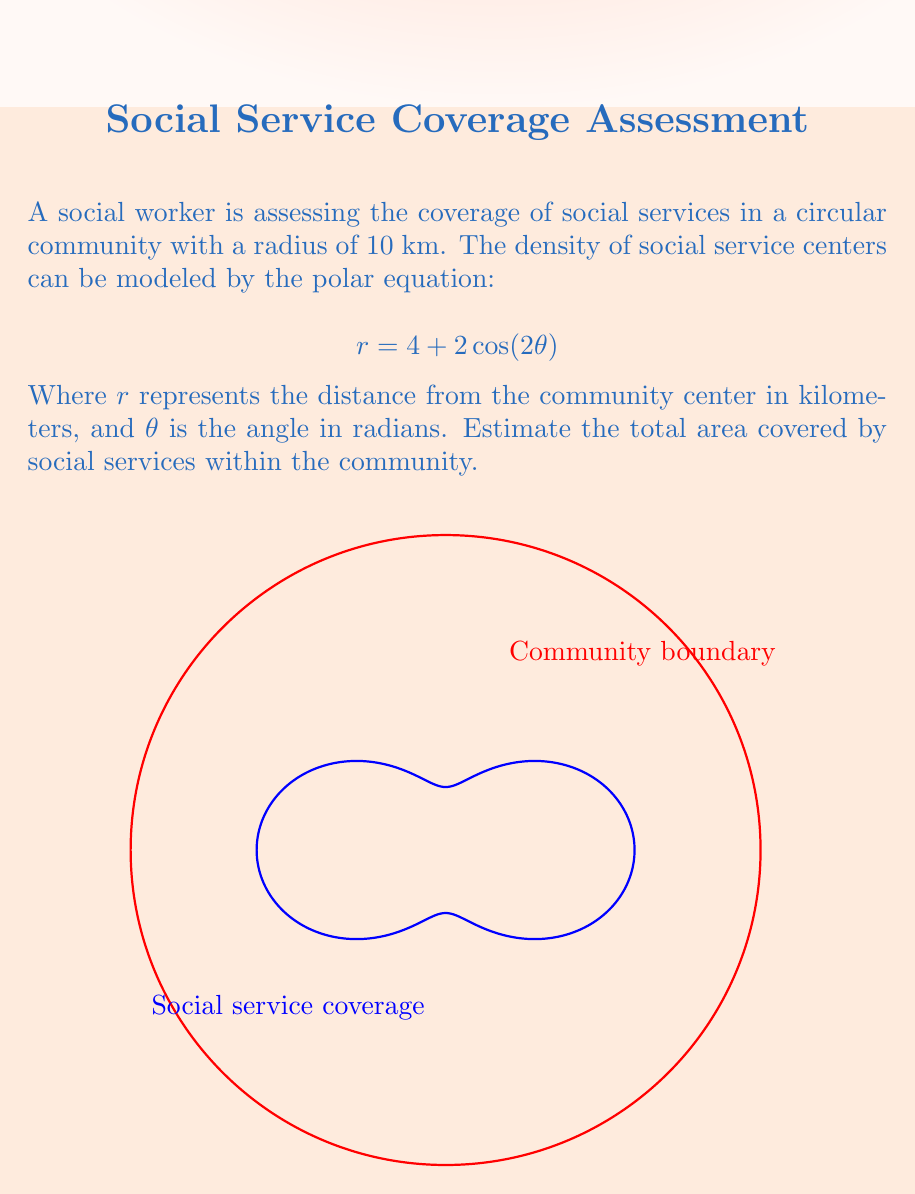Solve this math problem. To solve this problem, we need to follow these steps:

1) The area enclosed by a polar curve is given by the formula:

   $$A = \frac{1}{2} \int_{0}^{2\pi} r^2 d\theta$$

2) In our case, $r = 4 + 2\cos(2\theta)$. We need to square this:

   $$r^2 = (4 + 2\cos(2\theta))^2 = 16 + 16\cos(2\theta) + 4\cos^2(2\theta)$$

3) Now we can set up our integral:

   $$A = \frac{1}{2} \int_{0}^{2\pi} (16 + 16\cos(2\theta) + 4\cos^2(2\theta)) d\theta$$

4) Let's integrate each term:
   
   - $\int_{0}^{2\pi} 16 d\theta = 16\theta |_{0}^{2\pi} = 32\pi$
   
   - $\int_{0}^{2\pi} 16\cos(2\theta) d\theta = 8\sin(2\theta) |_{0}^{2\pi} = 0$
   
   - $\int_{0}^{2\pi} 4\cos^2(2\theta) d\theta = 2\theta + \sin(4\theta)/2 |_{0}^{2\pi} = 4\pi$

5) Adding these up:

   $$A = \frac{1}{2}(32\pi + 0 + 4\pi) = 18\pi$$

6) Therefore, the area covered by social services is $18\pi$ sq km.

7) However, we need to compare this with the total area of the community:

   $$A_{community} = \pi r^2 = \pi(10)^2 = 100\pi$$ sq km

8) The coverage percentage is:

   $$\text{Coverage} = \frac{18\pi}{100\pi} \times 100\% = 18\%$$
Answer: 18% of the community area 